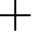<formula> <loc_0><loc_0><loc_500><loc_500>+</formula> 